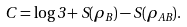<formula> <loc_0><loc_0><loc_500><loc_500>C = \log 3 + S ( \rho _ { B } ) - S ( \rho _ { A B } ) .</formula> 